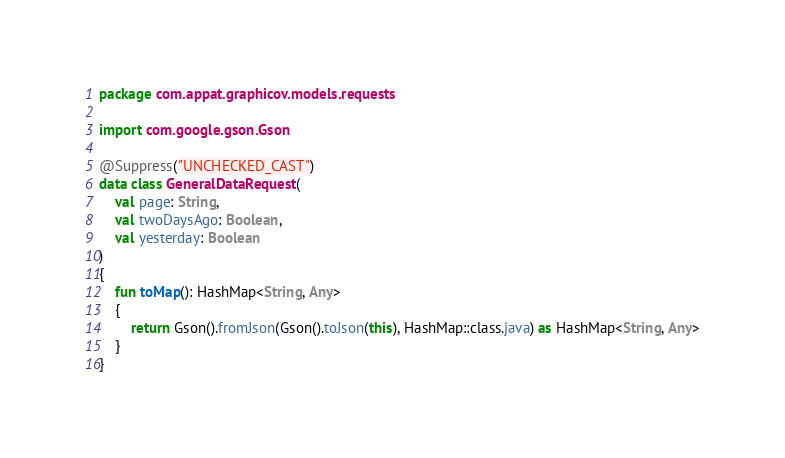Convert code to text. <code><loc_0><loc_0><loc_500><loc_500><_Kotlin_>package com.appat.graphicov.models.requests

import com.google.gson.Gson

@Suppress("UNCHECKED_CAST")
data class GeneralDataRequest(
    val page: String,
    val twoDaysAgo: Boolean,
    val yesterday: Boolean
)
{
    fun toMap(): HashMap<String, Any>
    {
        return Gson().fromJson(Gson().toJson(this), HashMap::class.java) as HashMap<String, Any>
    }
}</code> 